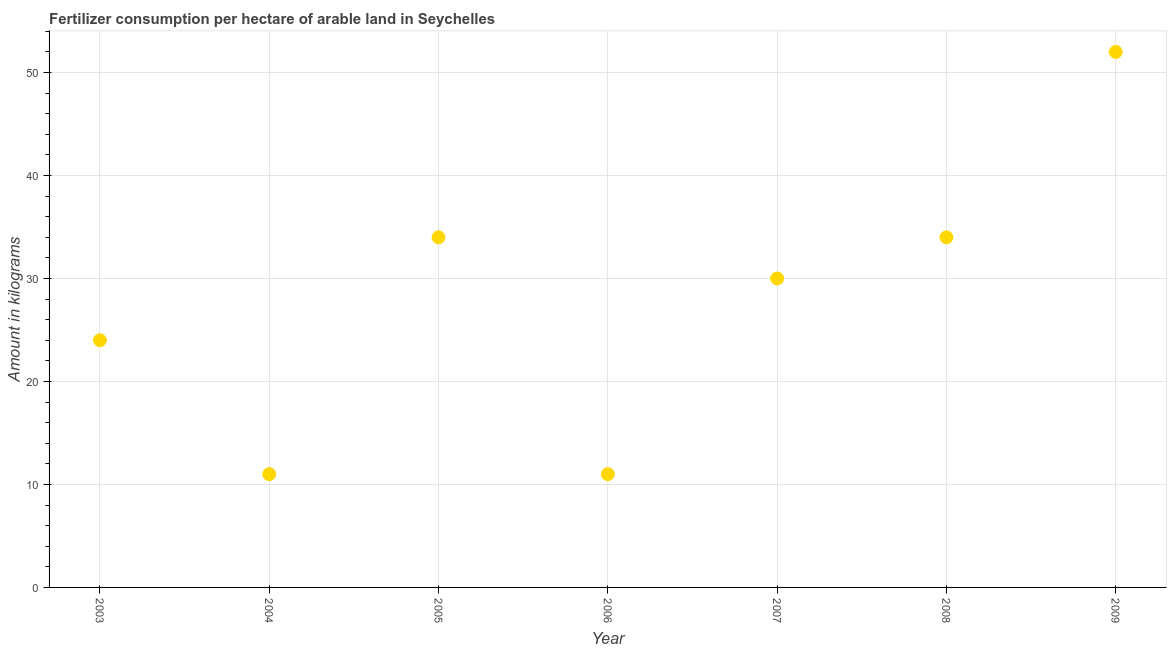Across all years, what is the maximum amount of fertilizer consumption?
Provide a succinct answer. 52. Across all years, what is the minimum amount of fertilizer consumption?
Offer a terse response. 11. In which year was the amount of fertilizer consumption minimum?
Provide a short and direct response. 2004. What is the sum of the amount of fertilizer consumption?
Offer a very short reply. 196. What is the average amount of fertilizer consumption per year?
Make the answer very short. 28. What is the median amount of fertilizer consumption?
Keep it short and to the point. 30. What is the ratio of the amount of fertilizer consumption in 2004 to that in 2008?
Your answer should be compact. 0.32. Is the amount of fertilizer consumption in 2005 less than that in 2006?
Offer a terse response. No. Is the difference between the amount of fertilizer consumption in 2004 and 2006 greater than the difference between any two years?
Provide a succinct answer. No. Is the sum of the amount of fertilizer consumption in 2003 and 2008 greater than the maximum amount of fertilizer consumption across all years?
Your answer should be very brief. Yes. What is the difference between the highest and the lowest amount of fertilizer consumption?
Your answer should be very brief. 41. In how many years, is the amount of fertilizer consumption greater than the average amount of fertilizer consumption taken over all years?
Provide a short and direct response. 4. How many dotlines are there?
Offer a terse response. 1. What is the difference between two consecutive major ticks on the Y-axis?
Offer a very short reply. 10. Does the graph contain any zero values?
Provide a succinct answer. No. What is the title of the graph?
Your answer should be compact. Fertilizer consumption per hectare of arable land in Seychelles . What is the label or title of the Y-axis?
Your response must be concise. Amount in kilograms. What is the Amount in kilograms in 2003?
Offer a terse response. 24. What is the Amount in kilograms in 2005?
Make the answer very short. 34. What is the Amount in kilograms in 2006?
Offer a very short reply. 11. What is the Amount in kilograms in 2007?
Provide a short and direct response. 30. What is the Amount in kilograms in 2009?
Make the answer very short. 52. What is the difference between the Amount in kilograms in 2003 and 2005?
Ensure brevity in your answer.  -10. What is the difference between the Amount in kilograms in 2003 and 2006?
Provide a short and direct response. 13. What is the difference between the Amount in kilograms in 2003 and 2009?
Your answer should be compact. -28. What is the difference between the Amount in kilograms in 2004 and 2005?
Make the answer very short. -23. What is the difference between the Amount in kilograms in 2004 and 2009?
Give a very brief answer. -41. What is the difference between the Amount in kilograms in 2005 and 2008?
Give a very brief answer. 0. What is the difference between the Amount in kilograms in 2006 and 2007?
Keep it short and to the point. -19. What is the difference between the Amount in kilograms in 2006 and 2008?
Your response must be concise. -23. What is the difference between the Amount in kilograms in 2006 and 2009?
Keep it short and to the point. -41. What is the difference between the Amount in kilograms in 2008 and 2009?
Offer a very short reply. -18. What is the ratio of the Amount in kilograms in 2003 to that in 2004?
Offer a terse response. 2.18. What is the ratio of the Amount in kilograms in 2003 to that in 2005?
Give a very brief answer. 0.71. What is the ratio of the Amount in kilograms in 2003 to that in 2006?
Your response must be concise. 2.18. What is the ratio of the Amount in kilograms in 2003 to that in 2007?
Offer a very short reply. 0.8. What is the ratio of the Amount in kilograms in 2003 to that in 2008?
Your response must be concise. 0.71. What is the ratio of the Amount in kilograms in 2003 to that in 2009?
Provide a short and direct response. 0.46. What is the ratio of the Amount in kilograms in 2004 to that in 2005?
Make the answer very short. 0.32. What is the ratio of the Amount in kilograms in 2004 to that in 2007?
Give a very brief answer. 0.37. What is the ratio of the Amount in kilograms in 2004 to that in 2008?
Offer a terse response. 0.32. What is the ratio of the Amount in kilograms in 2004 to that in 2009?
Your answer should be very brief. 0.21. What is the ratio of the Amount in kilograms in 2005 to that in 2006?
Your response must be concise. 3.09. What is the ratio of the Amount in kilograms in 2005 to that in 2007?
Provide a short and direct response. 1.13. What is the ratio of the Amount in kilograms in 2005 to that in 2009?
Your answer should be compact. 0.65. What is the ratio of the Amount in kilograms in 2006 to that in 2007?
Make the answer very short. 0.37. What is the ratio of the Amount in kilograms in 2006 to that in 2008?
Provide a short and direct response. 0.32. What is the ratio of the Amount in kilograms in 2006 to that in 2009?
Your response must be concise. 0.21. What is the ratio of the Amount in kilograms in 2007 to that in 2008?
Provide a short and direct response. 0.88. What is the ratio of the Amount in kilograms in 2007 to that in 2009?
Your answer should be compact. 0.58. What is the ratio of the Amount in kilograms in 2008 to that in 2009?
Give a very brief answer. 0.65. 